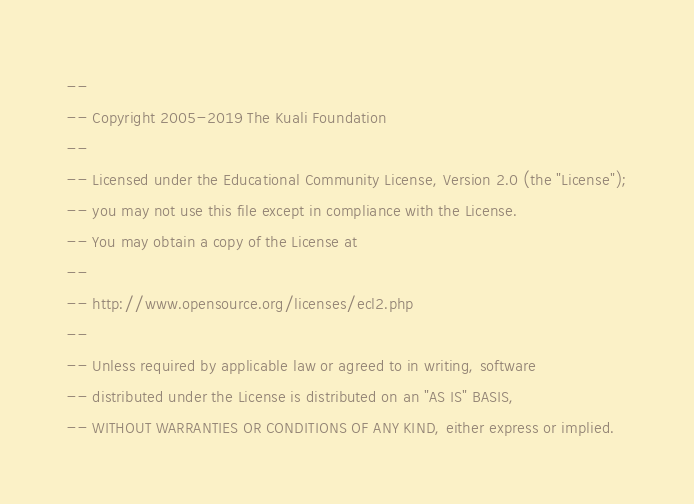<code> <loc_0><loc_0><loc_500><loc_500><_SQL_>--
-- Copyright 2005-2019 The Kuali Foundation
--
-- Licensed under the Educational Community License, Version 2.0 (the "License");
-- you may not use this file except in compliance with the License.
-- You may obtain a copy of the License at
--
-- http://www.opensource.org/licenses/ecl2.php
--
-- Unless required by applicable law or agreed to in writing, software
-- distributed under the License is distributed on an "AS IS" BASIS,
-- WITHOUT WARRANTIES OR CONDITIONS OF ANY KIND, either express or implied.</code> 